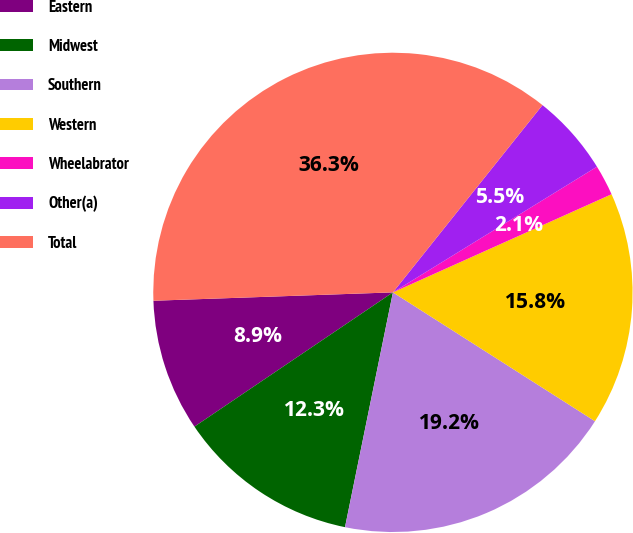Convert chart. <chart><loc_0><loc_0><loc_500><loc_500><pie_chart><fcel>Eastern<fcel>Midwest<fcel>Southern<fcel>Western<fcel>Wheelabrator<fcel>Other(a)<fcel>Total<nl><fcel>8.91%<fcel>12.33%<fcel>19.17%<fcel>15.75%<fcel>2.07%<fcel>5.49%<fcel>36.28%<nl></chart> 